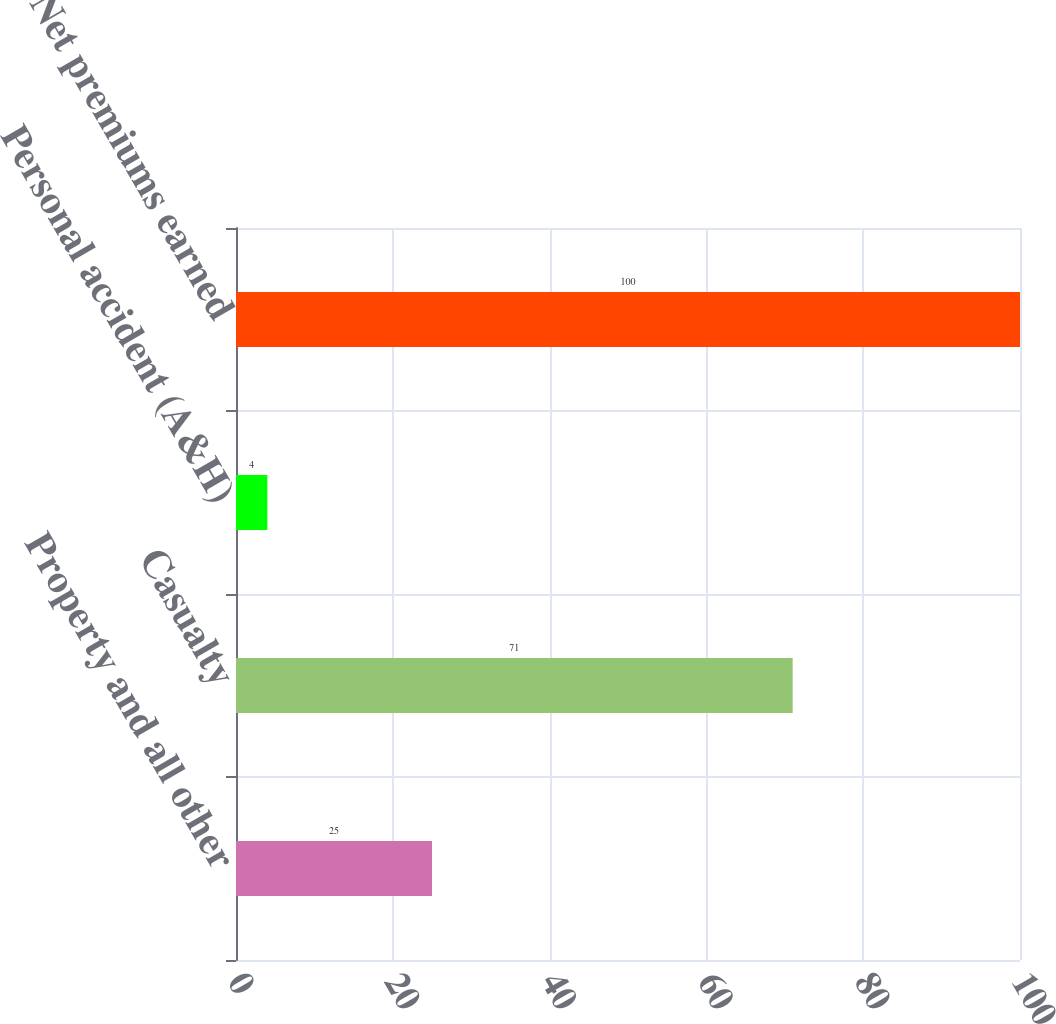Convert chart. <chart><loc_0><loc_0><loc_500><loc_500><bar_chart><fcel>Property and all other<fcel>Casualty<fcel>Personal accident (A&H)<fcel>Net premiums earned<nl><fcel>25<fcel>71<fcel>4<fcel>100<nl></chart> 